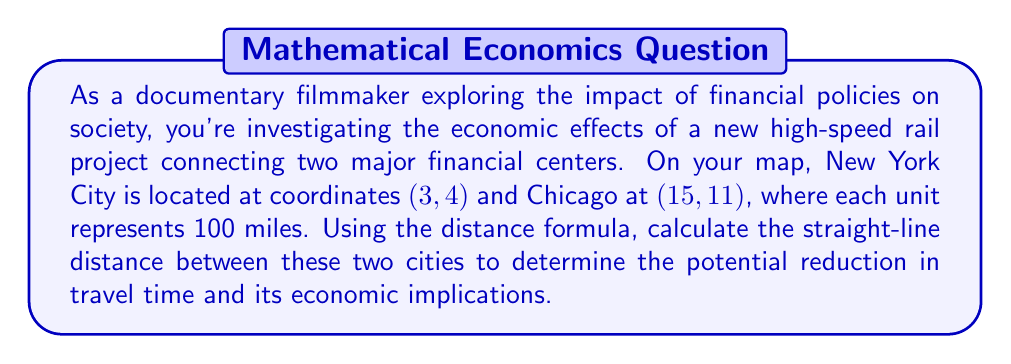Solve this math problem. To solve this problem, we'll use the distance formula derived from the Pythagorean theorem:

$$d = \sqrt{(x_2 - x_1)^2 + (y_2 - y_1)^2}$$

Where:
$(x_1, y_1)$ represents the coordinates of New York City (3, 4)
$(x_2, y_2)$ represents the coordinates of Chicago (15, 11)

Step 1: Substitute the values into the formula:
$$d = \sqrt{(15 - 3)^2 + (11 - 4)^2}$$

Step 2: Simplify the expressions inside the parentheses:
$$d = \sqrt{(12)^2 + (7)^2}$$

Step 3: Calculate the squares:
$$d = \sqrt{144 + 49}$$

Step 4: Add the values under the square root:
$$d = \sqrt{193}$$

Step 5: Simplify the square root:
$$d = 13.89$$

Step 6: Since each unit represents 100 miles, multiply the result by 100:
$$13.89 \times 100 = 1,389 \text{ miles}$$

This straight-line distance represents the potential route for the high-speed rail, which could significantly reduce travel time between these financial centers compared to current transportation methods.
Answer: 1,389 miles 